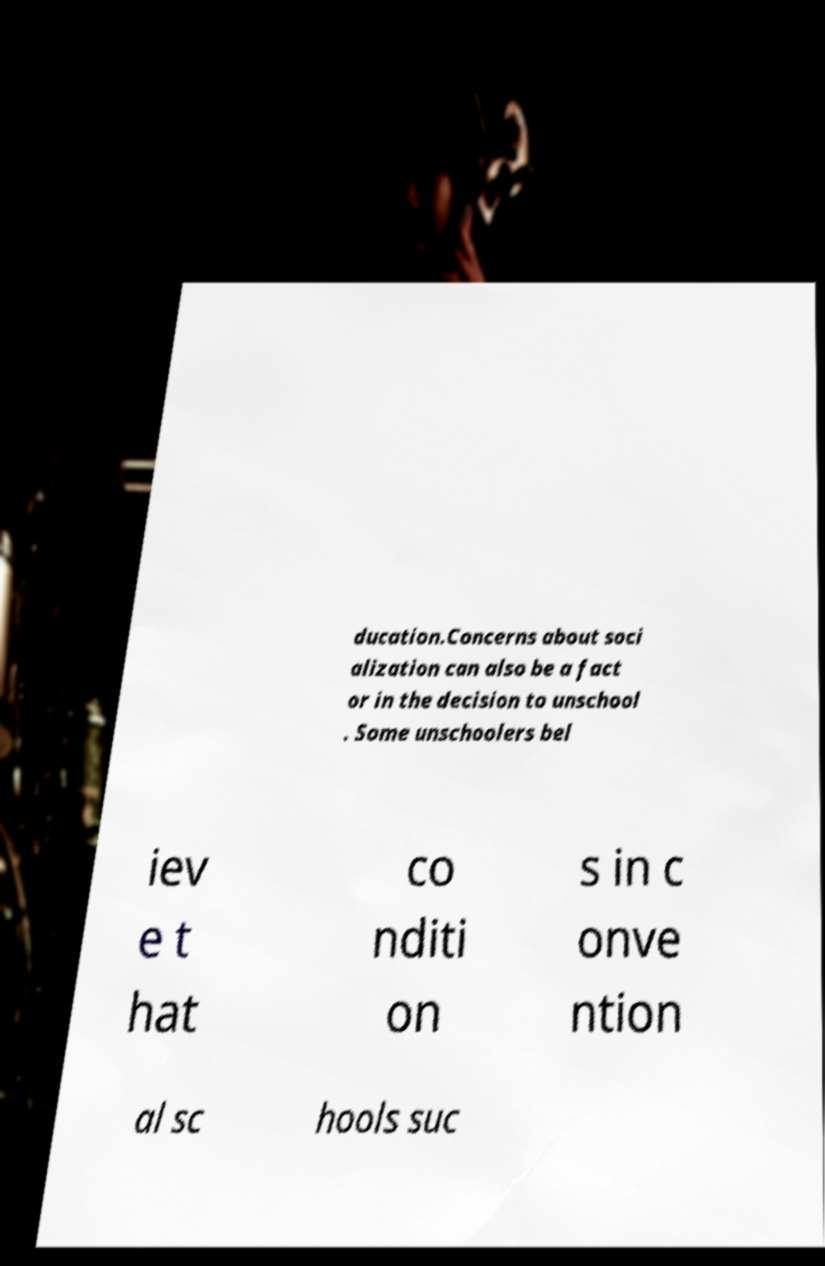There's text embedded in this image that I need extracted. Can you transcribe it verbatim? ducation.Concerns about soci alization can also be a fact or in the decision to unschool . Some unschoolers bel iev e t hat co nditi on s in c onve ntion al sc hools suc 